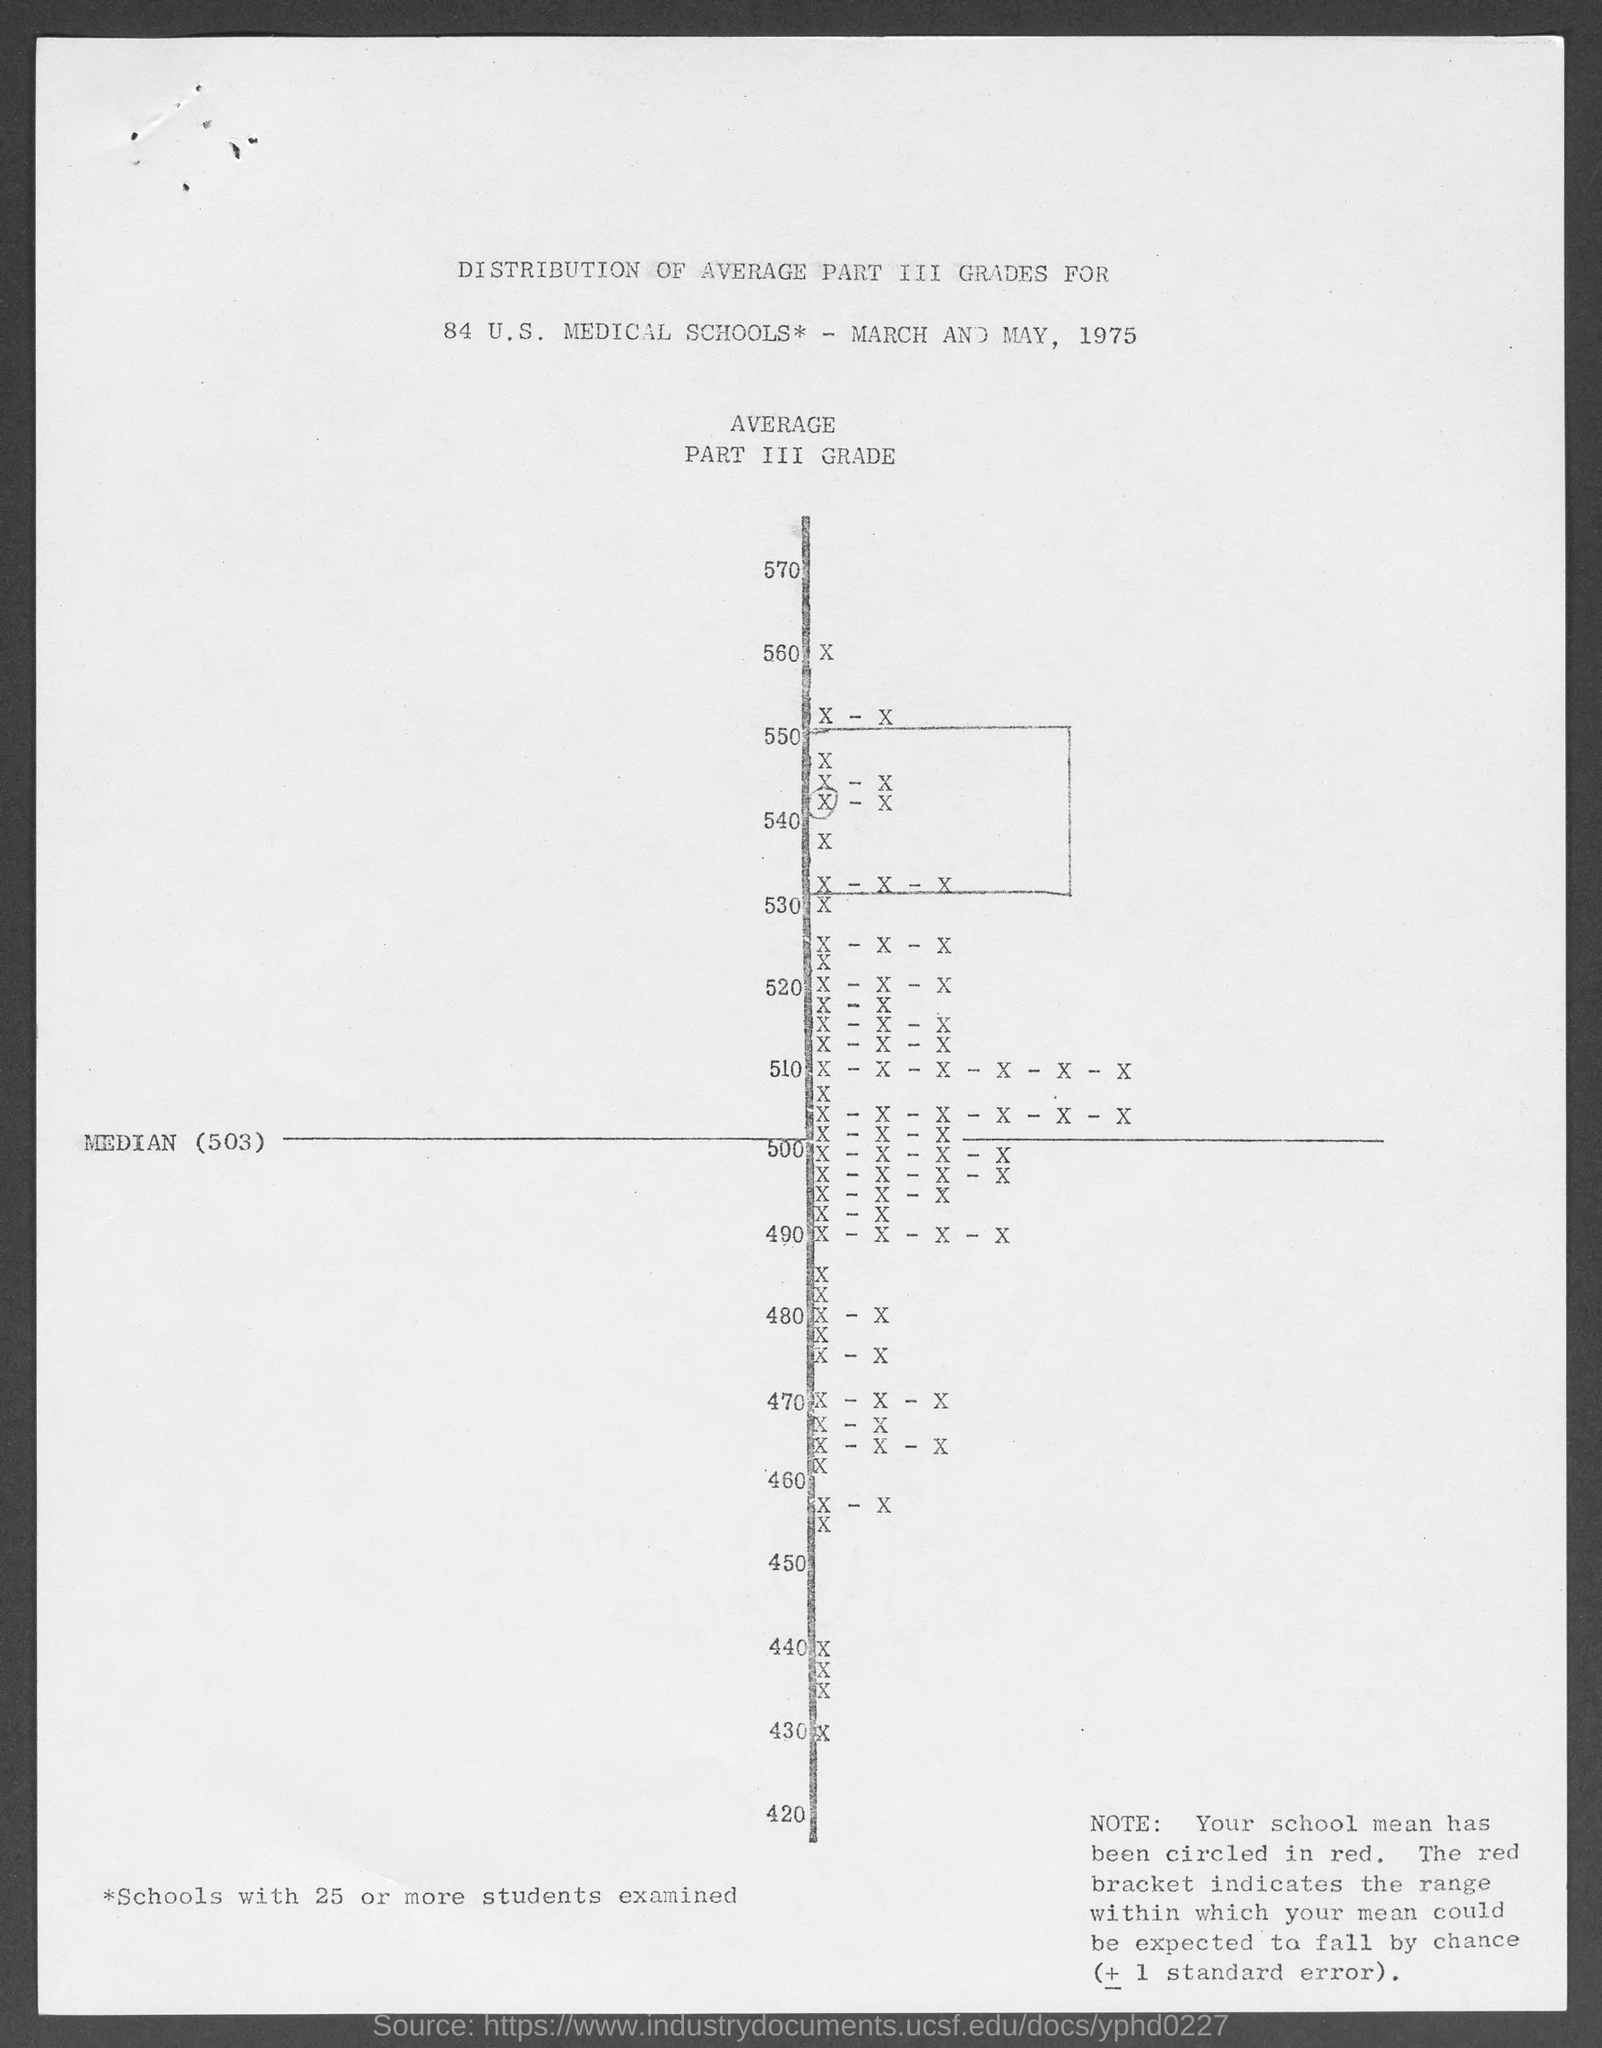What is the median value ?
Keep it short and to the point. 503. What is the highest value ?
Provide a succinct answer. 570. What is the lowest value ?
Your answer should be very brief. 420. Which year is shown in the document ?
Offer a very short reply. 1975. 